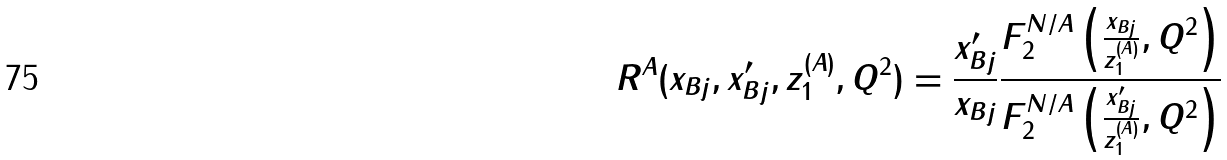<formula> <loc_0><loc_0><loc_500><loc_500>R ^ { A } ( x _ { B j } , x _ { B j } ^ { \prime } , z _ { 1 } ^ { ( A ) } , Q ^ { 2 } ) = { \frac { x _ { B j } ^ { \prime } } { x _ { B j } } } \frac { F _ { 2 } ^ { N / A } \left ( { \frac { x _ { B j } } { z _ { 1 } ^ { ( A ) } } } , Q ^ { 2 } \right ) } { F _ { 2 } ^ { N / A } \left ( { \frac { x _ { B j } ^ { \prime } } { z _ { 1 } ^ { ( A ) } } } , Q ^ { 2 } \right ) }</formula> 